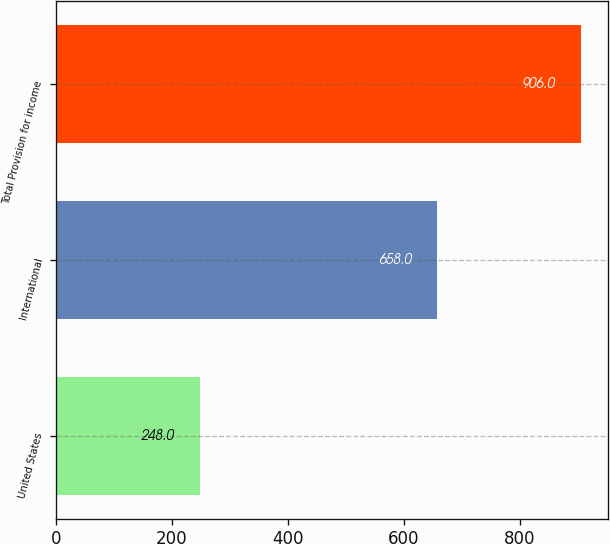Convert chart. <chart><loc_0><loc_0><loc_500><loc_500><bar_chart><fcel>United States<fcel>International<fcel>Total Provision for income<nl><fcel>248<fcel>658<fcel>906<nl></chart> 